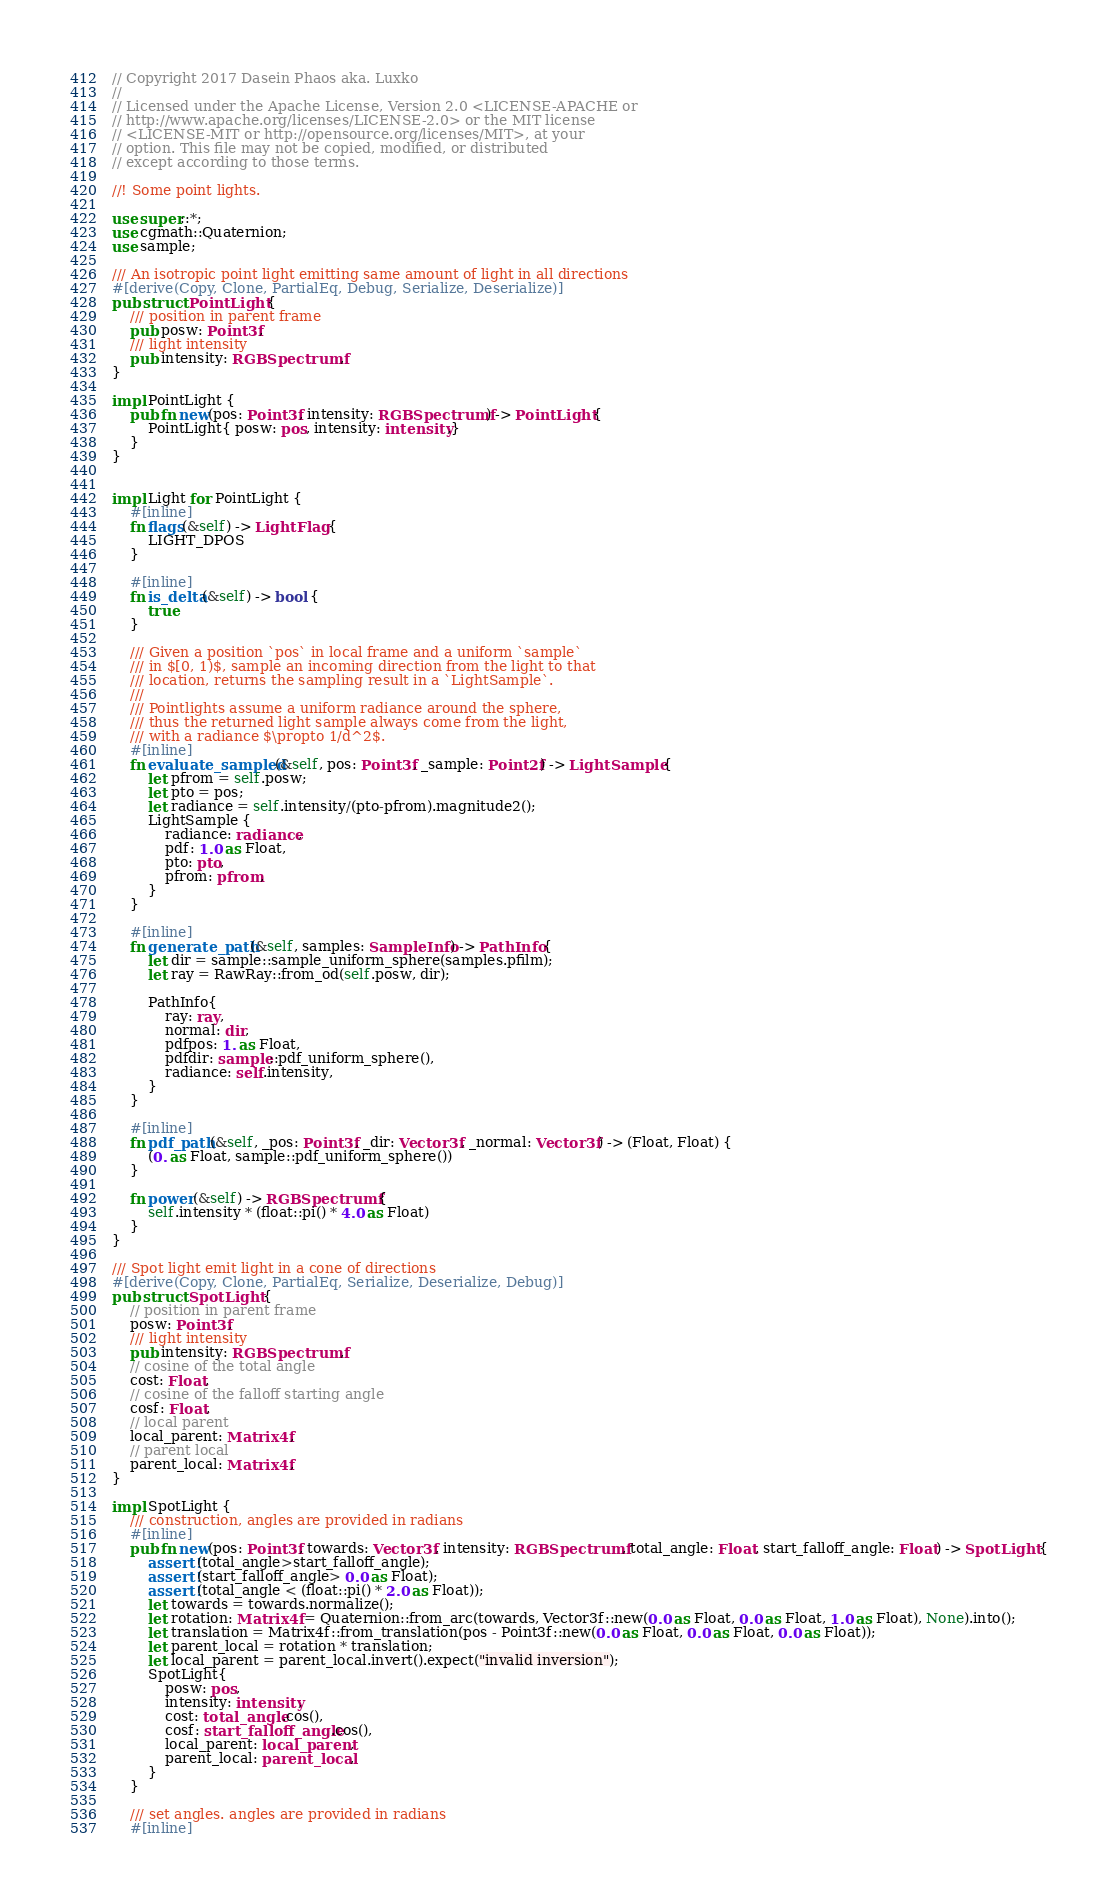Convert code to text. <code><loc_0><loc_0><loc_500><loc_500><_Rust_>// Copyright 2017 Dasein Phaos aka. Luxko
//
// Licensed under the Apache License, Version 2.0 <LICENSE-APACHE or
// http://www.apache.org/licenses/LICENSE-2.0> or the MIT license
// <LICENSE-MIT or http://opensource.org/licenses/MIT>, at your
// option. This file may not be copied, modified, or distributed
// except according to those terms.

//! Some point lights.

use super::*;
use cgmath::Quaternion;
use sample;

/// An isotropic point light emitting same amount of light in all directions
#[derive(Copy, Clone, PartialEq, Debug, Serialize, Deserialize)]
pub struct PointLight {
    /// position in parent frame
    pub posw: Point3f,
    /// light intensity
    pub intensity: RGBSpectrumf,
}

impl PointLight {
    pub fn new(pos: Point3f, intensity: RGBSpectrumf) -> PointLight {
        PointLight{ posw: pos, intensity: intensity,}
    }
}


impl Light for PointLight {
    #[inline]
    fn flags(&self) -> LightFlag {
        LIGHT_DPOS
    }

    #[inline]
    fn is_delta(&self) -> bool {
        true
    }

    /// Given a position `pos` in local frame and a uniform `sample`
    /// in $[0, 1)$, sample an incoming direction from the light to that
    /// location, returns the sampling result in a `LightSample`.
    ///
    /// Pointlights assume a uniform radiance around the sphere,
    /// thus the returned light sample always come from the light,
    /// with a radiance $\propto 1/d^2$. 
    #[inline]
    fn evaluate_sampled(&self, pos: Point3f, _sample: Point2f) -> LightSample {
        let pfrom = self.posw;
        let pto = pos;
        let radiance = self.intensity/(pto-pfrom).magnitude2();
        LightSample {
            radiance: radiance,
            pdf: 1.0 as Float,
            pto: pto,
            pfrom: pfrom,
        }
    }

    #[inline]
    fn generate_path(&self, samples: SampleInfo) -> PathInfo {
        let dir = sample::sample_uniform_sphere(samples.pfilm);
        let ray = RawRay::from_od(self.posw, dir);

        PathInfo{
            ray: ray,
            normal: dir,
            pdfpos: 1. as Float,
            pdfdir: sample::pdf_uniform_sphere(),
            radiance: self.intensity,
        }
    }

    #[inline]
    fn pdf_path(&self, _pos: Point3f, _dir: Vector3f, _normal: Vector3f) -> (Float, Float) {
        (0. as Float, sample::pdf_uniform_sphere())
    }

    fn power(&self) -> RGBSpectrumf {
        self.intensity * (float::pi() * 4.0 as Float)
    }
}

/// Spot light emit light in a cone of directions
#[derive(Copy, Clone, PartialEq, Serialize, Deserialize, Debug)]
pub struct SpotLight {
    // position in parent frame
    posw: Point3f,
    /// light intensity
    pub intensity: RGBSpectrumf,
    // cosine of the total angle
    cost: Float,
    // cosine of the falloff starting angle
    cosf: Float,
    // local parent
    local_parent: Matrix4f,
    // parent local
    parent_local: Matrix4f,
}

impl SpotLight {
    /// construction, angles are provided in radians
    #[inline]
    pub fn new(pos: Point3f, towards: Vector3f, intensity: RGBSpectrumf, total_angle: Float, start_falloff_angle: Float) -> SpotLight {
        assert!(total_angle>start_falloff_angle);
        assert!(start_falloff_angle> 0.0 as Float);
        assert!(total_angle < (float::pi() * 2.0 as Float));
        let towards = towards.normalize();
        let rotation: Matrix4f = Quaternion::from_arc(towards, Vector3f::new(0.0 as Float, 0.0 as Float, 1.0 as Float), None).into();
        let translation = Matrix4f::from_translation(pos - Point3f::new(0.0 as Float, 0.0 as Float, 0.0 as Float));
        let parent_local = rotation * translation;
        let local_parent = parent_local.invert().expect("invalid inversion");
        SpotLight{
            posw: pos,
            intensity: intensity,
            cost: total_angle.cos(),
            cosf: start_falloff_angle.cos(),
            local_parent: local_parent,
            parent_local: parent_local,
        }
    }

    /// set angles. angles are provided in radians
    #[inline]</code> 